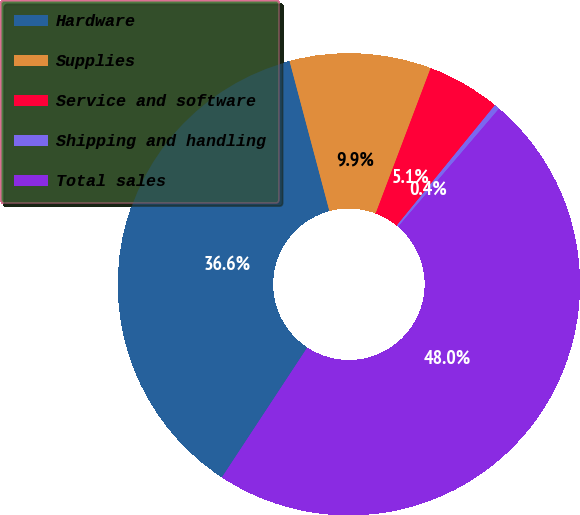Convert chart to OTSL. <chart><loc_0><loc_0><loc_500><loc_500><pie_chart><fcel>Hardware<fcel>Supplies<fcel>Service and software<fcel>Shipping and handling<fcel>Total sales<nl><fcel>36.61%<fcel>9.89%<fcel>5.13%<fcel>0.37%<fcel>48.0%<nl></chart> 